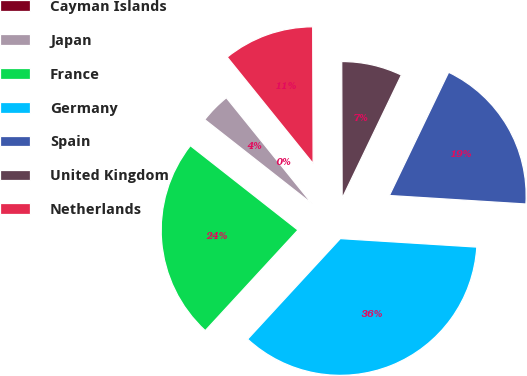Convert chart to OTSL. <chart><loc_0><loc_0><loc_500><loc_500><pie_chart><fcel>Cayman Islands<fcel>Japan<fcel>France<fcel>Germany<fcel>Spain<fcel>United Kingdom<fcel>Netherlands<nl><fcel>0.01%<fcel>3.59%<fcel>23.74%<fcel>35.86%<fcel>18.86%<fcel>7.18%<fcel>10.76%<nl></chart> 